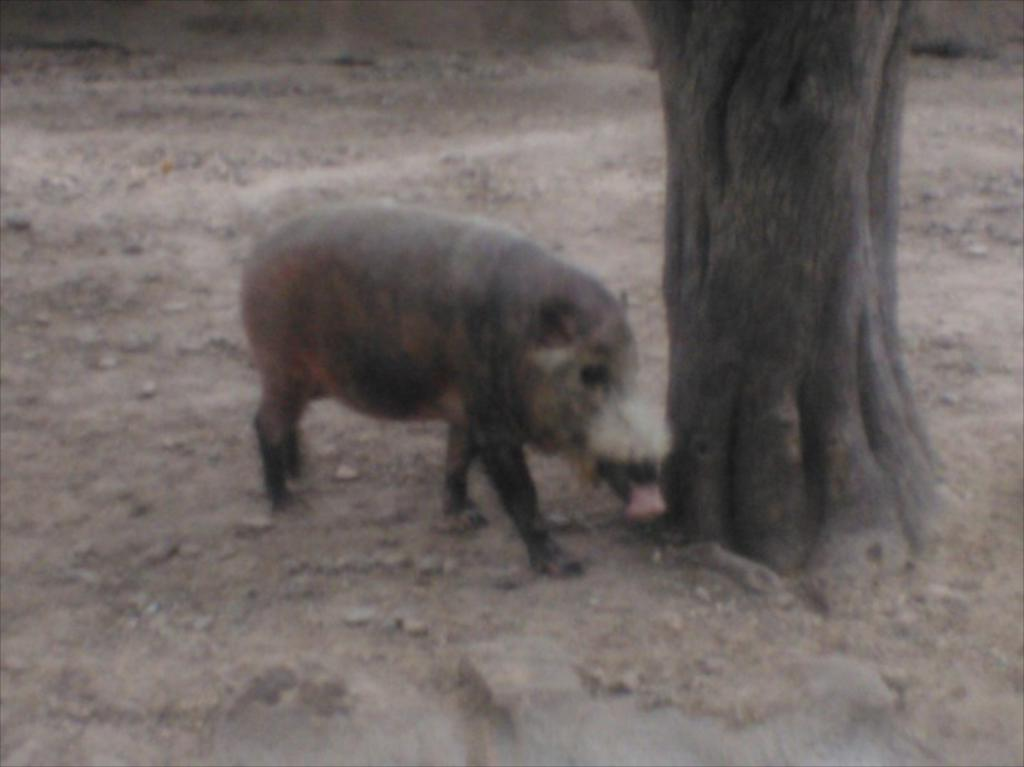What animal is present in the image? There is a pig in the image. Where is the pig located in relation to other objects in the image? The pig is standing beside a tree. What type of fruit is the queen holding in the image? There is no queen or fruit present in the image; it features a pig standing beside a tree. 